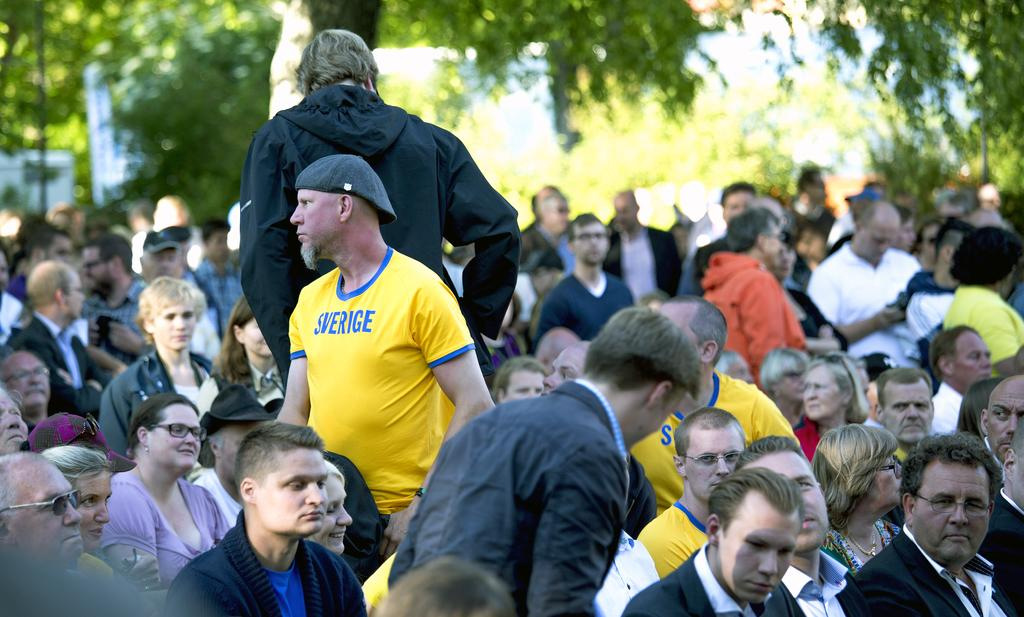What are the people in the image doing? There are persons standing and sitting in the image. Can you describe the background of the image? There are trees in the background of the image. What type of bead can be seen hanging from the icicle in the image? There is no icicle or bead present in the image. 